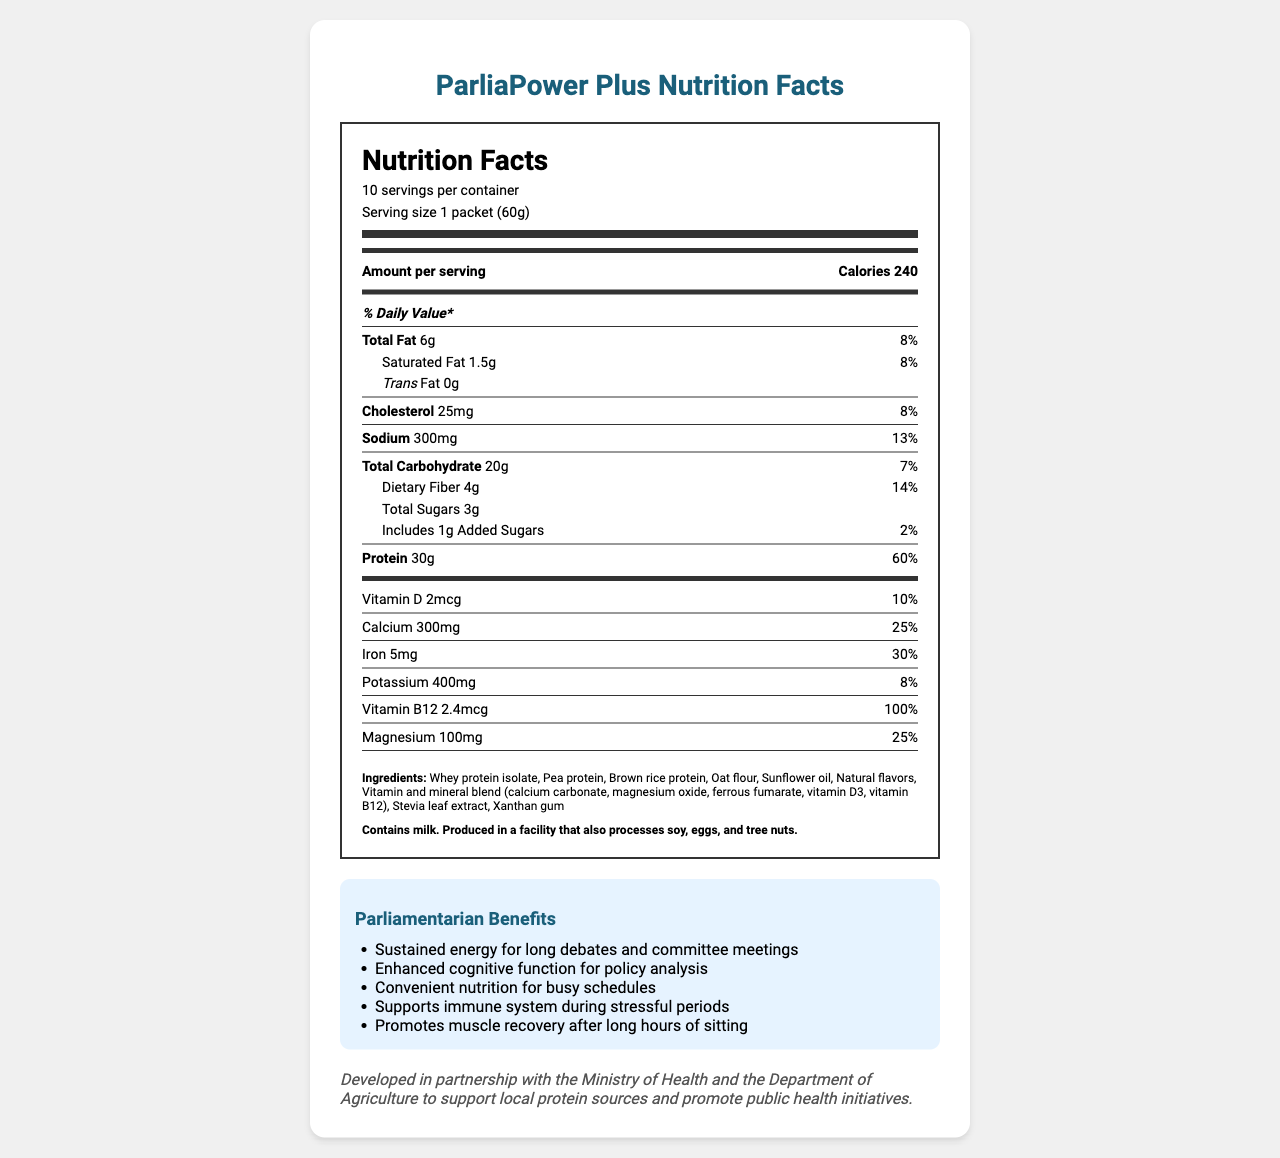what is the serving size? The serving size is explicitly stated as "1 packet (60g)" in the nutrition label.
Answer: 1 packet (60g) how many servings are in the container? The container has 10 servings, as mentioned in the label.
Answer: 10 how many grams of protein are in one serving? The nutrition facts mention that each serving contains 30g of protein.
Answer: 30g what is the daily value percentage for calcium? The daily value for calcium is specified as 25% in the label.
Answer: 25% how much dietary fiber is in each serving? Each serving contains 4 grams of dietary fiber, according to the label.
Answer: 4g which ingredient contributes to the sweetness of the product? A. Whey protein isolate B. Stevia leaf extract C. Sunflower oil D. Xanthan gum Stevia leaf extract is a natural sweetener, so it contributes to the sweetness of the product.
Answer: B what is the primary benefit mentioned for parliamentarians? A. Promotes muscle recovery B. Supports immune system C. Enhanced cognitive function D. Convenient nutrition While all the options are benefits, the primary context for busy schedules, which is a major concern for parliamentarians, is "Convenient nutrition."
Answer: D is the product dairy-free? The allergen info states that it contains milk, therefore the product is not dairy-free.
Answer: No can we determine how long a container will last for a parliamentarian who consumes one serving per day? If a parliamentarian consumes one serving per day, the container with 10 servings will last for 10 days.
Answer: 10 days describe the main benefits this product offers to parliamentarians. The benefits listed specifically aim to address the lifestyle and professional demands of parliamentarians, focusing on providing energy, cognitive support, convenience, immune support, and muscle recovery.
Answer: Sustained energy for long debates, enhanced cognitive function, convenient nutrition for busy schedules, supports immune system during stressful periods, and promotes muscle recovery after long hours of sitting. what is the total amount of sugars in a single serving? The document states that the total sugars in one serving are 3 grams.
Answer: 3g how should the product be stored? The storage instructions clearly mention that the product should be kept in a cool, dry place.
Answer: Store in a cool, dry place. what is the partnership mentioned in the economic policy connection? The document details an economic policy connection, where the product is developed in partnership with the Ministry of Health and the Department of Agriculture.
Answer: Partnership with the Ministry of Health and the Department of Agriculture does this product support local protein sources? (Yes/No) According to the economic policy connection, the product supports local protein sources.
Answer: Yes is the main source of protein plant-based or animal-based? The label lists both whey protein isolate (animal-based) and pea protein plus brown rice protein (plant-based), so it's unclear which is the predominant source based on the document alone.
Answer: Not enough information what is the daily value percentage for dietary fiber? The daily value percentage for dietary fiber is listed as 14% in the nutrition facts section.
Answer: 14% 